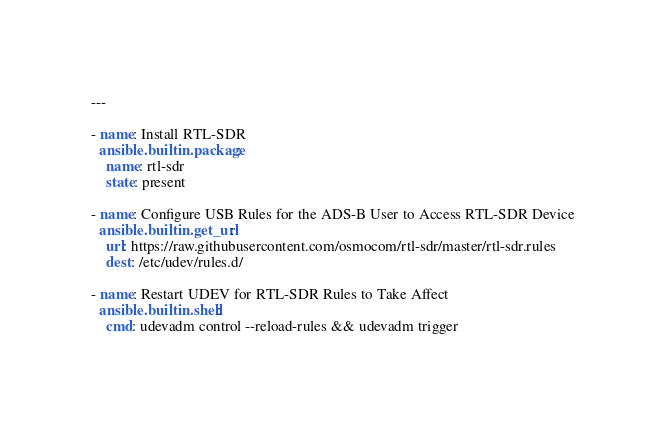<code> <loc_0><loc_0><loc_500><loc_500><_YAML_>---

- name: Install RTL-SDR
  ansible.builtin.package:
    name: rtl-sdr
    state: present

- name: Configure USB Rules for the ADS-B User to Access RTL-SDR Device
  ansible.builtin.get_url:
    url: https://raw.githubusercontent.com/osmocom/rtl-sdr/master/rtl-sdr.rules
    dest: /etc/udev/rules.d/

- name: Restart UDEV for RTL-SDR Rules to Take Affect
  ansible.builtin.shell:
    cmd: udevadm control --reload-rules && udevadm trigger
</code> 